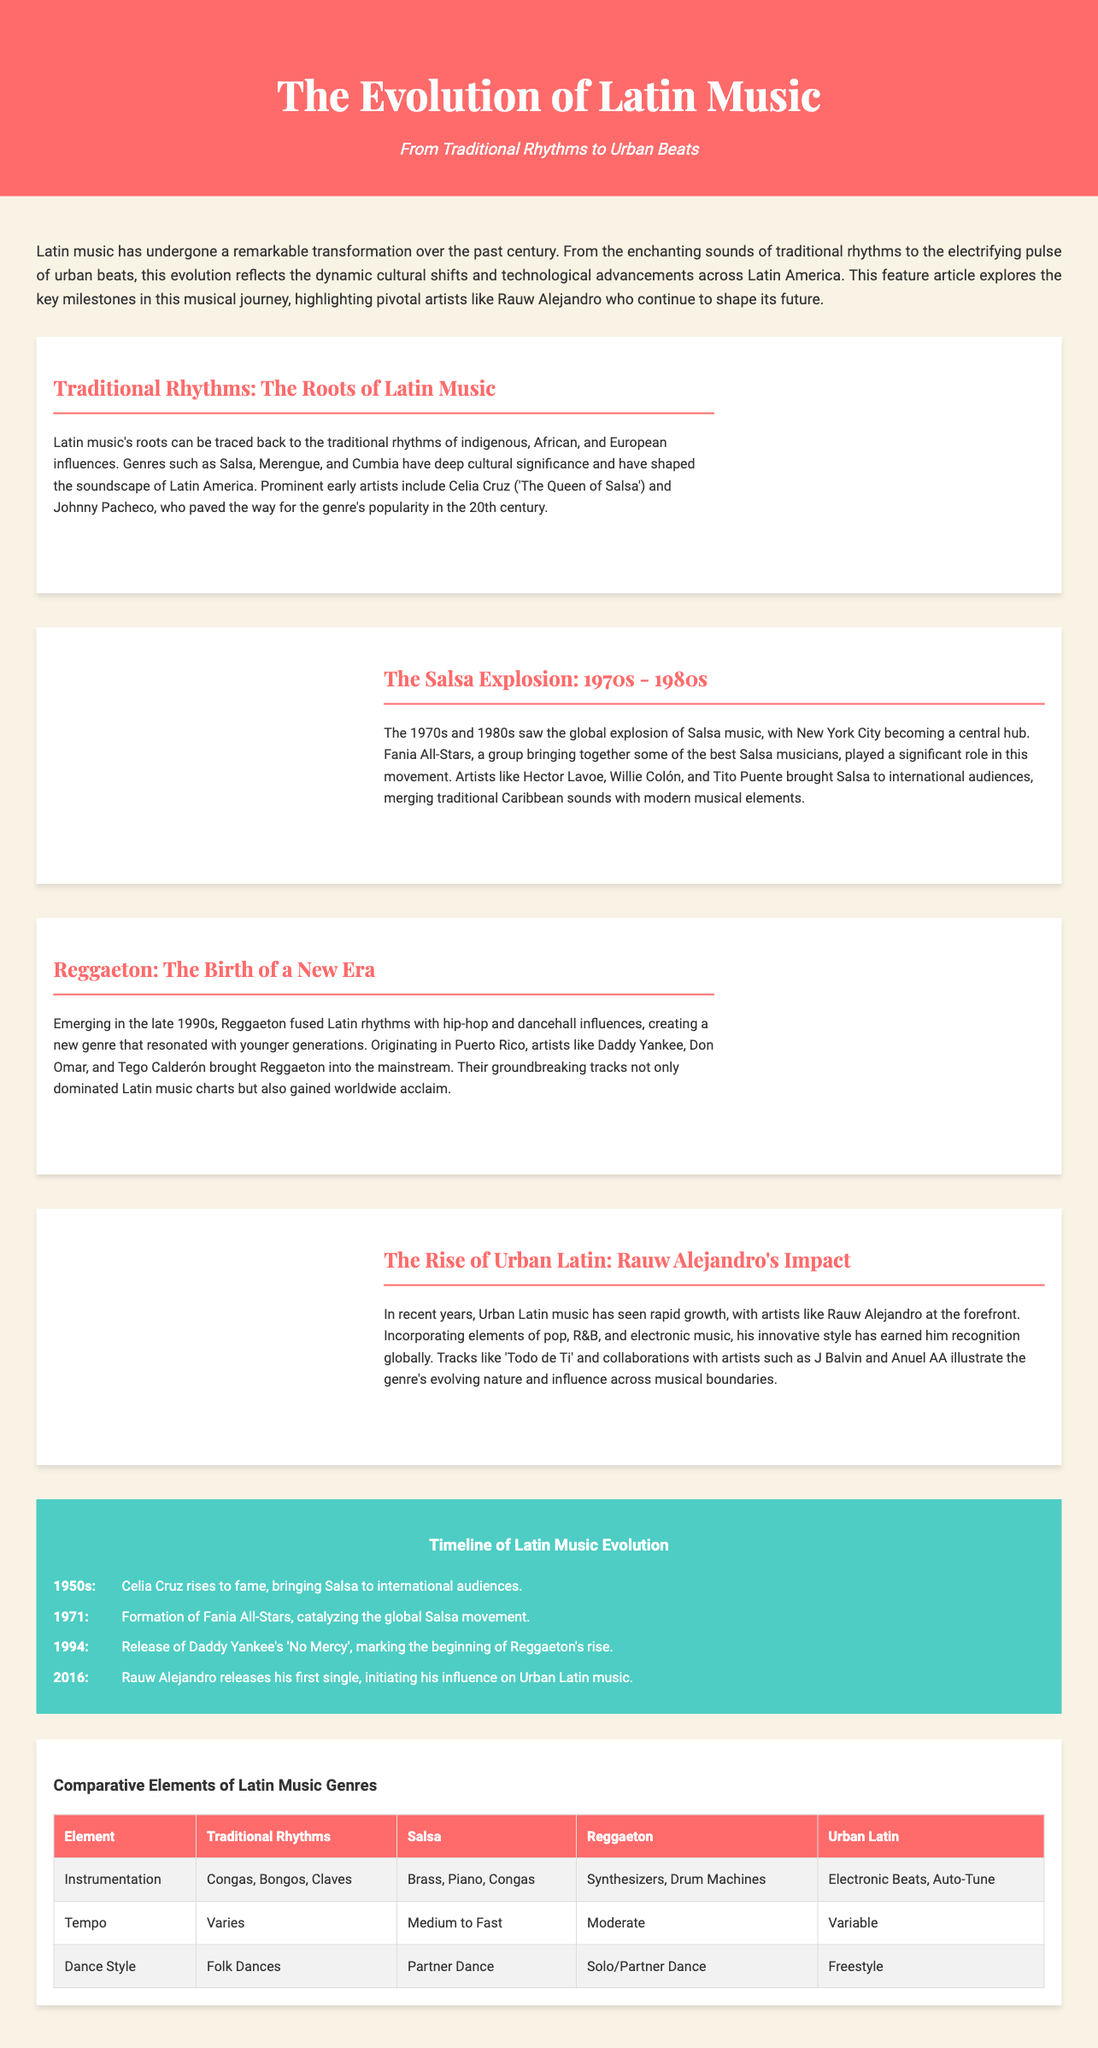What genre emerged in the late 1990s? The document states that Reggaeton emerged in the late 1990s, marking a new era in Latin music.
Answer: Reggaeton Who is referred to as 'The Queen of Salsa'? Celia Cruz is highlighted in the document as 'The Queen of Salsa', a significant figure in traditional Latin music.
Answer: Celia Cruz What year did Rauw Alejandro release his first single? The timeline indicates that Rauw Alejandro released his first single in 2016.
Answer: 2016 Which city became a central hub for Salsa music in the 1970s and 1980s? The document mentions New York City as a central hub for Salsa music during this time.
Answer: New York City What type of instrumentation is used in Reggaeton? The chart lists Synthesizers and Drum Machines as the instrumentation used in Reggaeton music.
Answer: Synthesizers, Drum Machines How does Urban Latin music differ from traditional rhythms in terms of instrumentation? The table shows that Urban Latin music incorporates Electronic Beats and Auto-Tune, unlike Traditional Rhythms.
Answer: Electronic Beats, Auto-Tune What was the timeline year when the Fania All-Stars were formed? The document includes that the Fania All-Stars were formed in 1971, marking a significant moment in Salsa music history.
Answer: 1971 What is the predominant dance style associated with Salsa music? According to the comparative elements table, the predominant dance style for Salsa is Partner Dance.
Answer: Partner Dance What is the tempo range for Salsa music as stated in the document? The document references that the typical tempo for Salsa music ranges from Medium to Fast.
Answer: Medium to Fast 